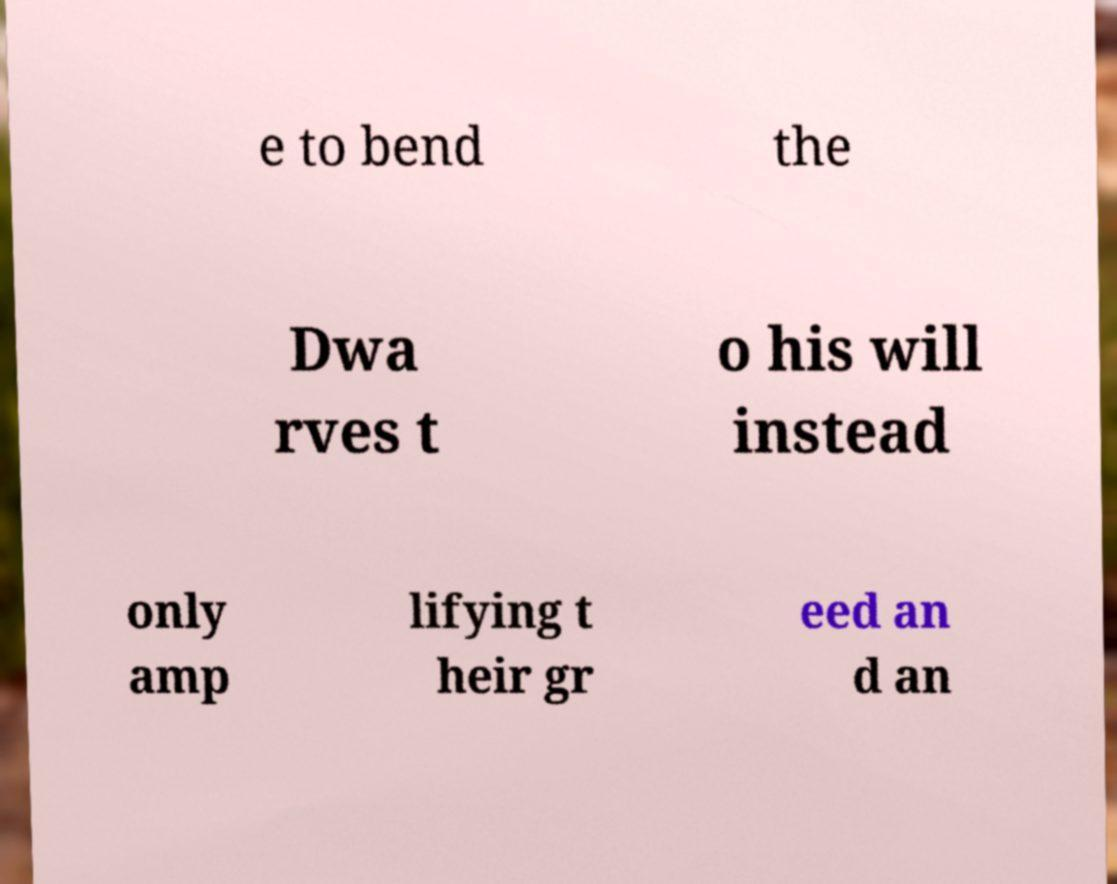What messages or text are displayed in this image? I need them in a readable, typed format. e to bend the Dwa rves t o his will instead only amp lifying t heir gr eed an d an 